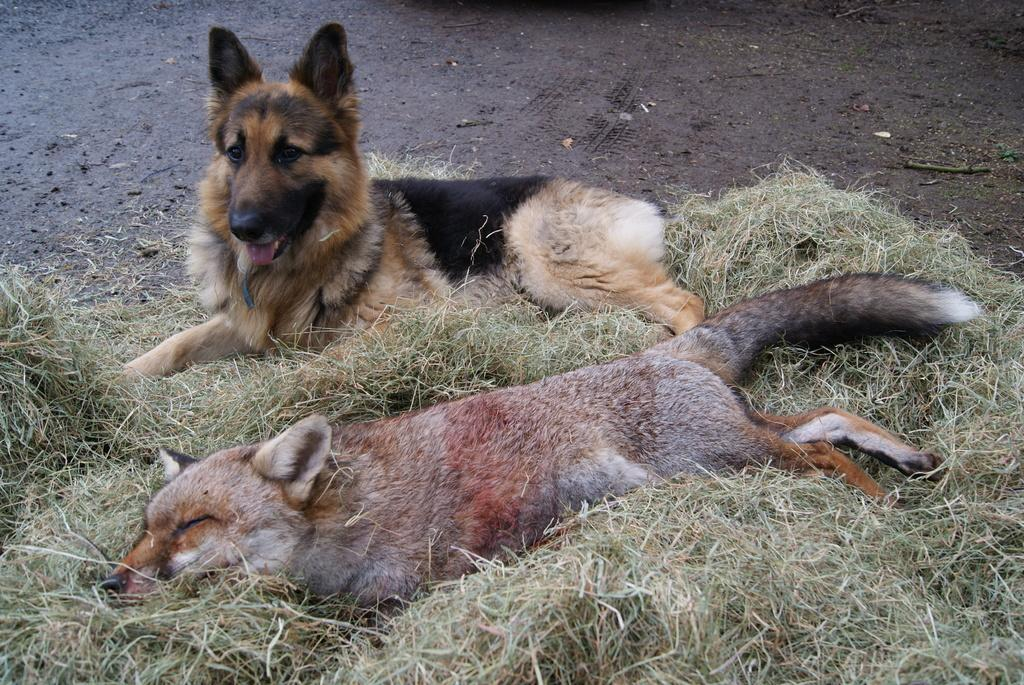How many dogs are present in the image? There are two dogs in the image. What are the dogs doing in the image? The dogs are laying on the grass. What type of surface can be seen at the top of the image? The ground is visible at the top of the image. What type of song is the dog wearing on its head in the image? There is no dog wearing a song or any other musical item in the image. 